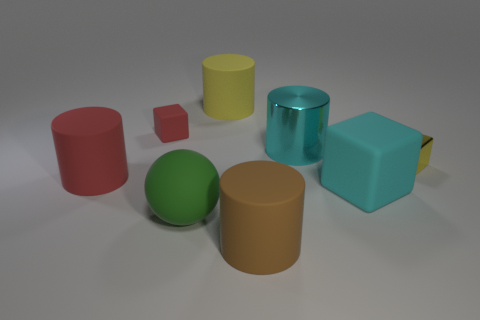Subtract all matte cubes. How many cubes are left? 1 Add 1 brown matte things. How many objects exist? 9 Subtract all brown cylinders. How many cylinders are left? 3 Subtract 1 cubes. How many cubes are left? 2 Subtract all gray cylinders. Subtract all brown blocks. How many cylinders are left? 4 Add 8 large cyan shiny things. How many large cyan shiny things exist? 9 Subtract 1 yellow blocks. How many objects are left? 7 Subtract all balls. How many objects are left? 7 Subtract all tiny metallic blocks. Subtract all big yellow cylinders. How many objects are left? 6 Add 7 cyan blocks. How many cyan blocks are left? 8 